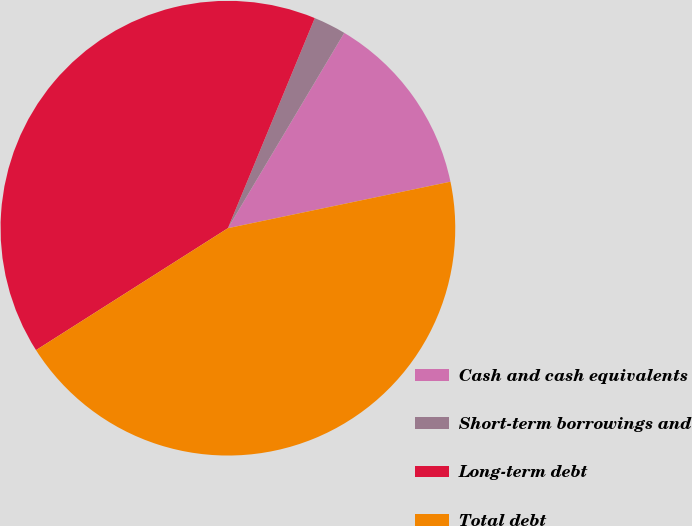<chart> <loc_0><loc_0><loc_500><loc_500><pie_chart><fcel>Cash and cash equivalents<fcel>Short-term borrowings and<fcel>Long-term debt<fcel>Total debt<nl><fcel>13.17%<fcel>2.31%<fcel>40.25%<fcel>44.27%<nl></chart> 